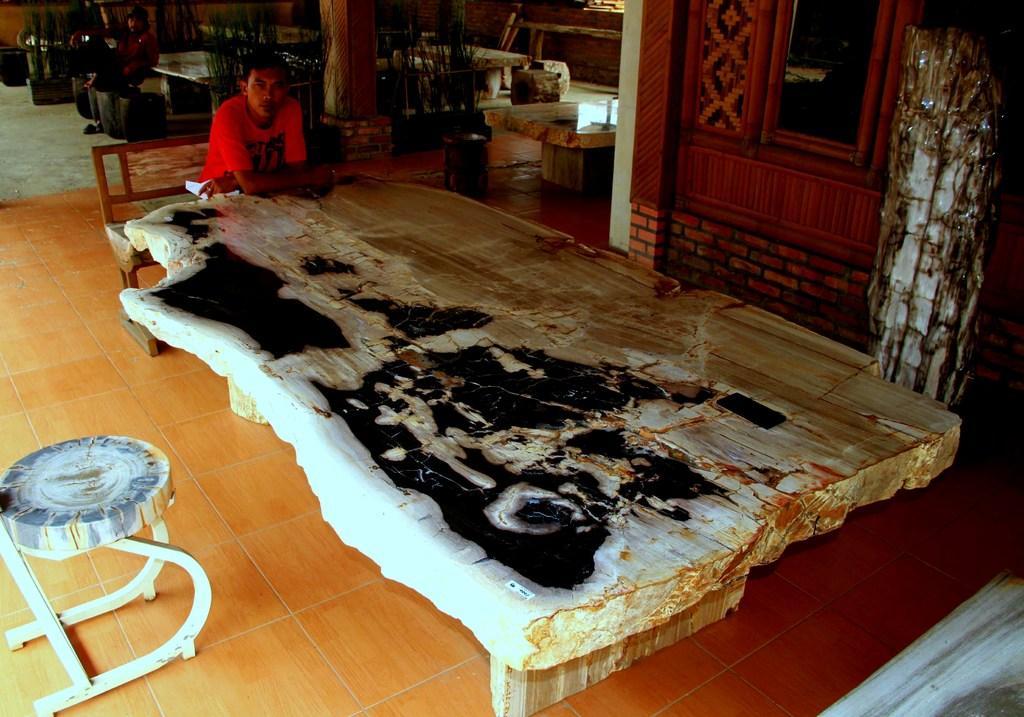Please provide a concise description of this image. In this picture we can see a man wearing red colour t shirt sitting on a bench in front of a table. This is a floor. Here we can see other person sitting. We can see all the empty tables and chair. 